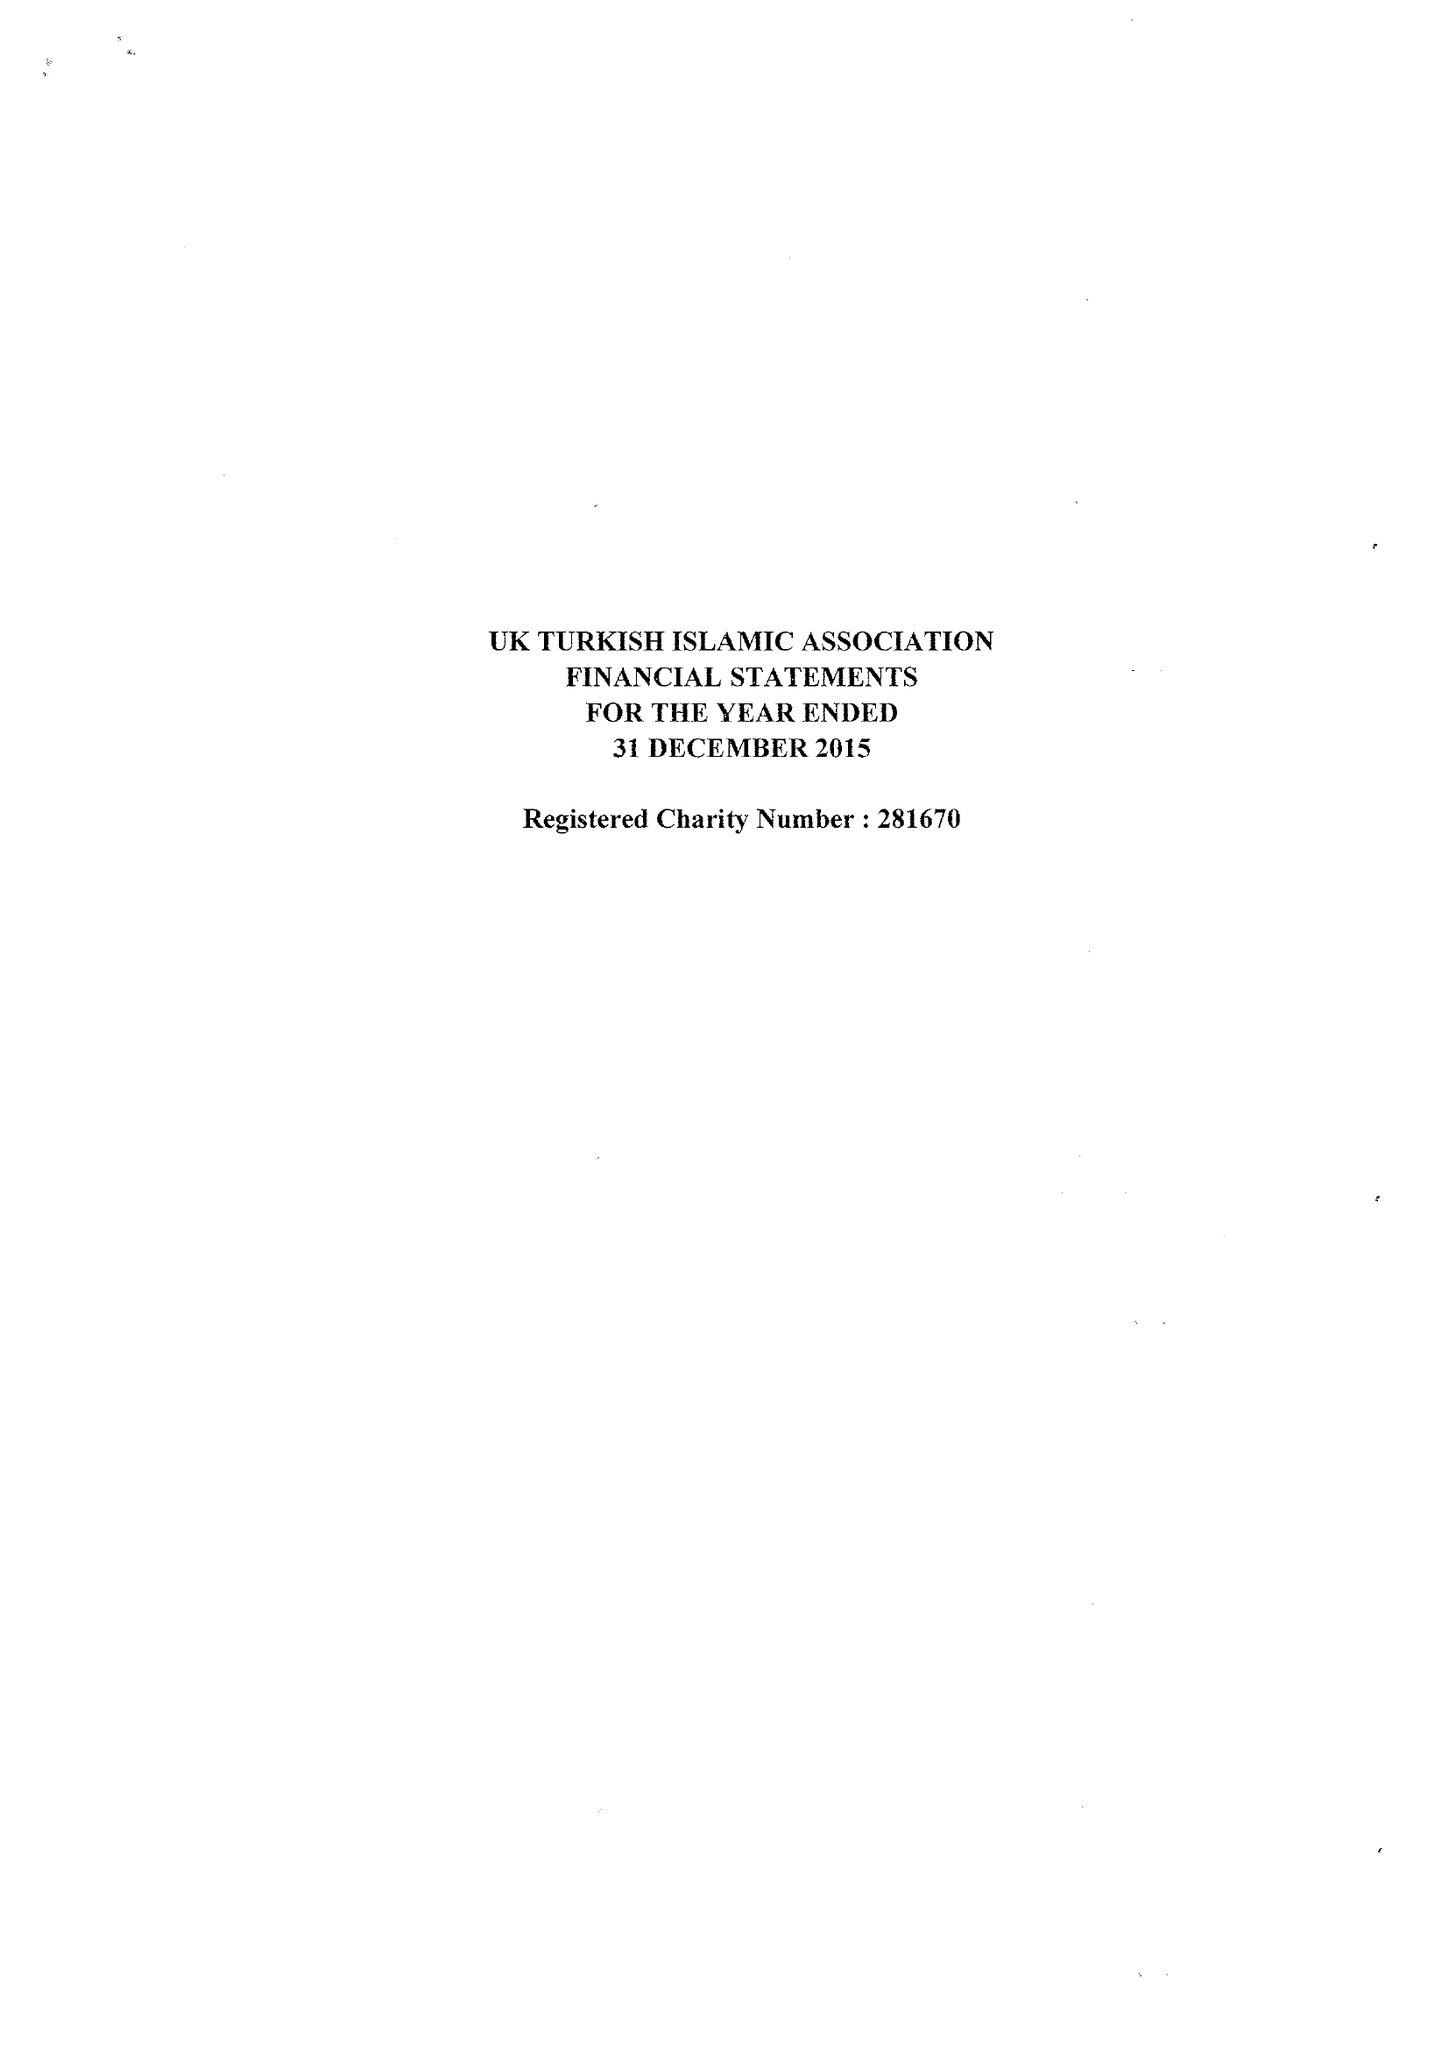What is the value for the address__postcode?
Answer the question using a single word or phrase. N16 8BU 